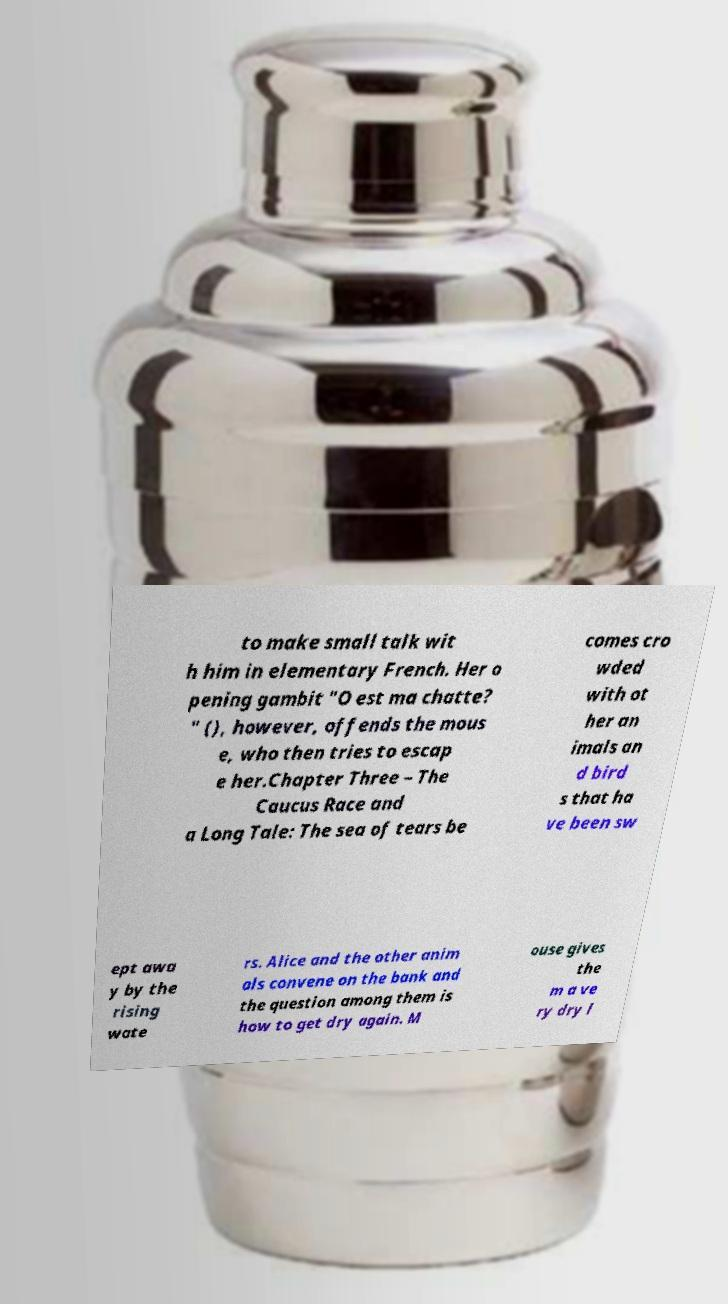Could you assist in decoding the text presented in this image and type it out clearly? to make small talk wit h him in elementary French. Her o pening gambit "O est ma chatte? " (), however, offends the mous e, who then tries to escap e her.Chapter Three – The Caucus Race and a Long Tale: The sea of tears be comes cro wded with ot her an imals an d bird s that ha ve been sw ept awa y by the rising wate rs. Alice and the other anim als convene on the bank and the question among them is how to get dry again. M ouse gives the m a ve ry dry l 